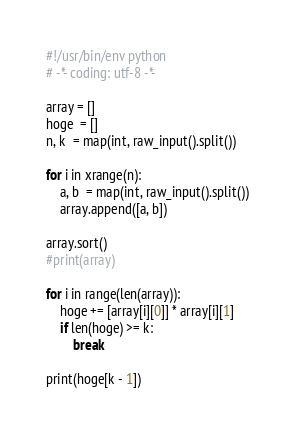<code> <loc_0><loc_0><loc_500><loc_500><_Python_>#!/usr/bin/env python
# -*- coding: utf-8 -*-

array = []
hoge  = []
n, k  = map(int, raw_input().split())

for i in xrange(n):
	a, b  = map(int, raw_input().split())
	array.append([a, b])

array.sort()
#print(array)

for i in range(len(array)):
	hoge += [array[i][0]] * array[i][1]
	if len(hoge) >= k:
		break

print(hoge[k - 1])
</code> 